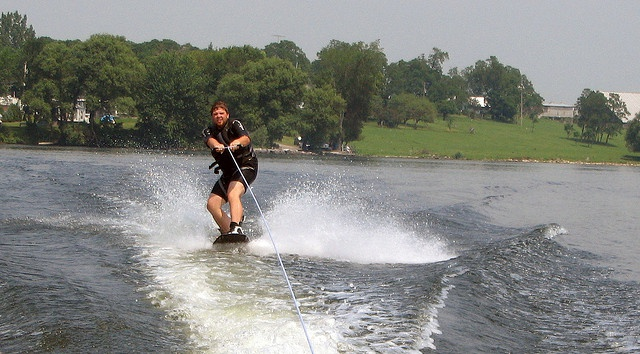Describe the objects in this image and their specific colors. I can see people in darkgray, black, brown, maroon, and salmon tones and surfboard in darkgray, black, gray, and maroon tones in this image. 